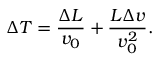Convert formula to latex. <formula><loc_0><loc_0><loc_500><loc_500>\Delta T = \frac { \Delta L } { v _ { 0 } } + \frac { L \Delta v } { v _ { 0 } ^ { 2 } } .</formula> 